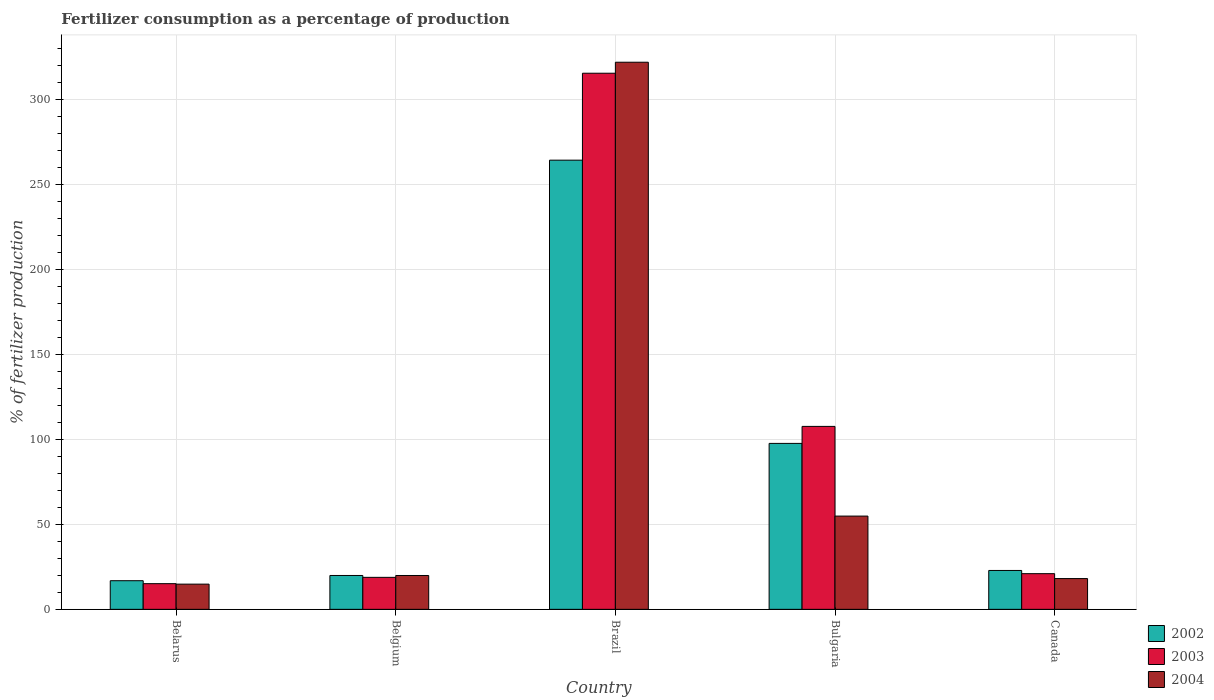How many different coloured bars are there?
Your response must be concise. 3. Are the number of bars per tick equal to the number of legend labels?
Provide a short and direct response. Yes. Are the number of bars on each tick of the X-axis equal?
Make the answer very short. Yes. What is the label of the 2nd group of bars from the left?
Give a very brief answer. Belgium. In how many cases, is the number of bars for a given country not equal to the number of legend labels?
Keep it short and to the point. 0. What is the percentage of fertilizers consumed in 2003 in Brazil?
Provide a succinct answer. 315.68. Across all countries, what is the maximum percentage of fertilizers consumed in 2003?
Offer a terse response. 315.68. Across all countries, what is the minimum percentage of fertilizers consumed in 2004?
Your answer should be very brief. 14.84. In which country was the percentage of fertilizers consumed in 2003 minimum?
Ensure brevity in your answer.  Belarus. What is the total percentage of fertilizers consumed in 2003 in the graph?
Offer a very short reply. 478.35. What is the difference between the percentage of fertilizers consumed in 2002 in Bulgaria and that in Canada?
Provide a short and direct response. 74.82. What is the difference between the percentage of fertilizers consumed in 2004 in Brazil and the percentage of fertilizers consumed in 2002 in Belarus?
Ensure brevity in your answer.  305.3. What is the average percentage of fertilizers consumed in 2003 per country?
Keep it short and to the point. 95.67. What is the difference between the percentage of fertilizers consumed of/in 2004 and percentage of fertilizers consumed of/in 2003 in Bulgaria?
Your response must be concise. -52.8. What is the ratio of the percentage of fertilizers consumed in 2002 in Belarus to that in Bulgaria?
Your answer should be compact. 0.17. Is the percentage of fertilizers consumed in 2003 in Belarus less than that in Bulgaria?
Provide a succinct answer. Yes. Is the difference between the percentage of fertilizers consumed in 2004 in Belarus and Brazil greater than the difference between the percentage of fertilizers consumed in 2003 in Belarus and Brazil?
Your answer should be very brief. No. What is the difference between the highest and the second highest percentage of fertilizers consumed in 2003?
Your response must be concise. -207.97. What is the difference between the highest and the lowest percentage of fertilizers consumed in 2003?
Your answer should be compact. 300.57. In how many countries, is the percentage of fertilizers consumed in 2002 greater than the average percentage of fertilizers consumed in 2002 taken over all countries?
Ensure brevity in your answer.  2. Is the sum of the percentage of fertilizers consumed in 2002 in Belarus and Canada greater than the maximum percentage of fertilizers consumed in 2004 across all countries?
Make the answer very short. No. What does the 1st bar from the right in Brazil represents?
Offer a very short reply. 2004. Is it the case that in every country, the sum of the percentage of fertilizers consumed in 2004 and percentage of fertilizers consumed in 2002 is greater than the percentage of fertilizers consumed in 2003?
Your answer should be compact. Yes. How many bars are there?
Ensure brevity in your answer.  15. How many countries are there in the graph?
Your response must be concise. 5. Does the graph contain any zero values?
Your answer should be compact. No. Where does the legend appear in the graph?
Provide a succinct answer. Bottom right. What is the title of the graph?
Offer a terse response. Fertilizer consumption as a percentage of production. What is the label or title of the Y-axis?
Your answer should be compact. % of fertilizer production. What is the % of fertilizer production of 2002 in Belarus?
Make the answer very short. 16.86. What is the % of fertilizer production of 2003 in Belarus?
Make the answer very short. 15.11. What is the % of fertilizer production of 2004 in Belarus?
Your answer should be compact. 14.84. What is the % of fertilizer production of 2002 in Belgium?
Provide a short and direct response. 19.94. What is the % of fertilizer production of 2003 in Belgium?
Make the answer very short. 18.83. What is the % of fertilizer production of 2004 in Belgium?
Your response must be concise. 19.93. What is the % of fertilizer production in 2002 in Brazil?
Offer a very short reply. 264.49. What is the % of fertilizer production in 2003 in Brazil?
Give a very brief answer. 315.68. What is the % of fertilizer production of 2004 in Brazil?
Make the answer very short. 322.16. What is the % of fertilizer production of 2002 in Bulgaria?
Provide a succinct answer. 97.71. What is the % of fertilizer production of 2003 in Bulgaria?
Give a very brief answer. 107.72. What is the % of fertilizer production of 2004 in Bulgaria?
Provide a short and direct response. 54.91. What is the % of fertilizer production of 2002 in Canada?
Provide a short and direct response. 22.89. What is the % of fertilizer production of 2003 in Canada?
Offer a terse response. 21. What is the % of fertilizer production of 2004 in Canada?
Offer a terse response. 18.12. Across all countries, what is the maximum % of fertilizer production in 2002?
Provide a succinct answer. 264.49. Across all countries, what is the maximum % of fertilizer production of 2003?
Keep it short and to the point. 315.68. Across all countries, what is the maximum % of fertilizer production in 2004?
Provide a succinct answer. 322.16. Across all countries, what is the minimum % of fertilizer production in 2002?
Make the answer very short. 16.86. Across all countries, what is the minimum % of fertilizer production in 2003?
Give a very brief answer. 15.11. Across all countries, what is the minimum % of fertilizer production of 2004?
Make the answer very short. 14.84. What is the total % of fertilizer production of 2002 in the graph?
Give a very brief answer. 421.89. What is the total % of fertilizer production of 2003 in the graph?
Make the answer very short. 478.35. What is the total % of fertilizer production in 2004 in the graph?
Your answer should be very brief. 429.96. What is the difference between the % of fertilizer production of 2002 in Belarus and that in Belgium?
Make the answer very short. -3.08. What is the difference between the % of fertilizer production of 2003 in Belarus and that in Belgium?
Your response must be concise. -3.72. What is the difference between the % of fertilizer production of 2004 in Belarus and that in Belgium?
Your answer should be compact. -5.09. What is the difference between the % of fertilizer production of 2002 in Belarus and that in Brazil?
Make the answer very short. -247.63. What is the difference between the % of fertilizer production in 2003 in Belarus and that in Brazil?
Make the answer very short. -300.57. What is the difference between the % of fertilizer production in 2004 in Belarus and that in Brazil?
Your answer should be very brief. -307.31. What is the difference between the % of fertilizer production of 2002 in Belarus and that in Bulgaria?
Offer a very short reply. -80.85. What is the difference between the % of fertilizer production in 2003 in Belarus and that in Bulgaria?
Give a very brief answer. -92.61. What is the difference between the % of fertilizer production of 2004 in Belarus and that in Bulgaria?
Your response must be concise. -40.07. What is the difference between the % of fertilizer production in 2002 in Belarus and that in Canada?
Ensure brevity in your answer.  -6.03. What is the difference between the % of fertilizer production in 2003 in Belarus and that in Canada?
Give a very brief answer. -5.89. What is the difference between the % of fertilizer production of 2004 in Belarus and that in Canada?
Provide a succinct answer. -3.27. What is the difference between the % of fertilizer production in 2002 in Belgium and that in Brazil?
Ensure brevity in your answer.  -244.55. What is the difference between the % of fertilizer production in 2003 in Belgium and that in Brazil?
Your answer should be very brief. -296.85. What is the difference between the % of fertilizer production of 2004 in Belgium and that in Brazil?
Your answer should be compact. -302.23. What is the difference between the % of fertilizer production of 2002 in Belgium and that in Bulgaria?
Provide a succinct answer. -77.77. What is the difference between the % of fertilizer production of 2003 in Belgium and that in Bulgaria?
Provide a succinct answer. -88.89. What is the difference between the % of fertilizer production in 2004 in Belgium and that in Bulgaria?
Keep it short and to the point. -34.98. What is the difference between the % of fertilizer production of 2002 in Belgium and that in Canada?
Make the answer very short. -2.95. What is the difference between the % of fertilizer production in 2003 in Belgium and that in Canada?
Offer a very short reply. -2.17. What is the difference between the % of fertilizer production of 2004 in Belgium and that in Canada?
Your answer should be very brief. 1.81. What is the difference between the % of fertilizer production of 2002 in Brazil and that in Bulgaria?
Keep it short and to the point. 166.78. What is the difference between the % of fertilizer production of 2003 in Brazil and that in Bulgaria?
Keep it short and to the point. 207.97. What is the difference between the % of fertilizer production of 2004 in Brazil and that in Bulgaria?
Your answer should be compact. 267.25. What is the difference between the % of fertilizer production in 2002 in Brazil and that in Canada?
Your answer should be compact. 241.6. What is the difference between the % of fertilizer production in 2003 in Brazil and that in Canada?
Provide a succinct answer. 294.68. What is the difference between the % of fertilizer production in 2004 in Brazil and that in Canada?
Provide a succinct answer. 304.04. What is the difference between the % of fertilizer production of 2002 in Bulgaria and that in Canada?
Your answer should be compact. 74.82. What is the difference between the % of fertilizer production of 2003 in Bulgaria and that in Canada?
Make the answer very short. 86.71. What is the difference between the % of fertilizer production in 2004 in Bulgaria and that in Canada?
Ensure brevity in your answer.  36.8. What is the difference between the % of fertilizer production in 2002 in Belarus and the % of fertilizer production in 2003 in Belgium?
Give a very brief answer. -1.97. What is the difference between the % of fertilizer production of 2002 in Belarus and the % of fertilizer production of 2004 in Belgium?
Offer a very short reply. -3.07. What is the difference between the % of fertilizer production of 2003 in Belarus and the % of fertilizer production of 2004 in Belgium?
Offer a very short reply. -4.82. What is the difference between the % of fertilizer production of 2002 in Belarus and the % of fertilizer production of 2003 in Brazil?
Provide a succinct answer. -298.83. What is the difference between the % of fertilizer production of 2002 in Belarus and the % of fertilizer production of 2004 in Brazil?
Provide a succinct answer. -305.3. What is the difference between the % of fertilizer production of 2003 in Belarus and the % of fertilizer production of 2004 in Brazil?
Ensure brevity in your answer.  -307.05. What is the difference between the % of fertilizer production of 2002 in Belarus and the % of fertilizer production of 2003 in Bulgaria?
Offer a terse response. -90.86. What is the difference between the % of fertilizer production of 2002 in Belarus and the % of fertilizer production of 2004 in Bulgaria?
Offer a very short reply. -38.05. What is the difference between the % of fertilizer production of 2003 in Belarus and the % of fertilizer production of 2004 in Bulgaria?
Offer a very short reply. -39.8. What is the difference between the % of fertilizer production of 2002 in Belarus and the % of fertilizer production of 2003 in Canada?
Provide a short and direct response. -4.15. What is the difference between the % of fertilizer production of 2002 in Belarus and the % of fertilizer production of 2004 in Canada?
Ensure brevity in your answer.  -1.26. What is the difference between the % of fertilizer production of 2003 in Belarus and the % of fertilizer production of 2004 in Canada?
Your answer should be compact. -3.01. What is the difference between the % of fertilizer production in 2002 in Belgium and the % of fertilizer production in 2003 in Brazil?
Ensure brevity in your answer.  -295.74. What is the difference between the % of fertilizer production in 2002 in Belgium and the % of fertilizer production in 2004 in Brazil?
Offer a very short reply. -302.22. What is the difference between the % of fertilizer production in 2003 in Belgium and the % of fertilizer production in 2004 in Brazil?
Give a very brief answer. -303.33. What is the difference between the % of fertilizer production of 2002 in Belgium and the % of fertilizer production of 2003 in Bulgaria?
Your answer should be very brief. -87.78. What is the difference between the % of fertilizer production of 2002 in Belgium and the % of fertilizer production of 2004 in Bulgaria?
Ensure brevity in your answer.  -34.97. What is the difference between the % of fertilizer production in 2003 in Belgium and the % of fertilizer production in 2004 in Bulgaria?
Offer a very short reply. -36.08. What is the difference between the % of fertilizer production in 2002 in Belgium and the % of fertilizer production in 2003 in Canada?
Offer a terse response. -1.06. What is the difference between the % of fertilizer production of 2002 in Belgium and the % of fertilizer production of 2004 in Canada?
Your answer should be compact. 1.82. What is the difference between the % of fertilizer production in 2003 in Belgium and the % of fertilizer production in 2004 in Canada?
Provide a short and direct response. 0.71. What is the difference between the % of fertilizer production in 2002 in Brazil and the % of fertilizer production in 2003 in Bulgaria?
Provide a short and direct response. 156.77. What is the difference between the % of fertilizer production of 2002 in Brazil and the % of fertilizer production of 2004 in Bulgaria?
Your answer should be compact. 209.58. What is the difference between the % of fertilizer production in 2003 in Brazil and the % of fertilizer production in 2004 in Bulgaria?
Offer a very short reply. 260.77. What is the difference between the % of fertilizer production of 2002 in Brazil and the % of fertilizer production of 2003 in Canada?
Provide a short and direct response. 243.49. What is the difference between the % of fertilizer production of 2002 in Brazil and the % of fertilizer production of 2004 in Canada?
Ensure brevity in your answer.  246.37. What is the difference between the % of fertilizer production in 2003 in Brazil and the % of fertilizer production in 2004 in Canada?
Your answer should be compact. 297.57. What is the difference between the % of fertilizer production of 2002 in Bulgaria and the % of fertilizer production of 2003 in Canada?
Provide a succinct answer. 76.71. What is the difference between the % of fertilizer production of 2002 in Bulgaria and the % of fertilizer production of 2004 in Canada?
Your answer should be compact. 79.59. What is the difference between the % of fertilizer production of 2003 in Bulgaria and the % of fertilizer production of 2004 in Canada?
Your answer should be compact. 89.6. What is the average % of fertilizer production of 2002 per country?
Your response must be concise. 84.38. What is the average % of fertilizer production in 2003 per country?
Provide a succinct answer. 95.67. What is the average % of fertilizer production in 2004 per country?
Keep it short and to the point. 85.99. What is the difference between the % of fertilizer production in 2002 and % of fertilizer production in 2003 in Belarus?
Ensure brevity in your answer.  1.75. What is the difference between the % of fertilizer production of 2002 and % of fertilizer production of 2004 in Belarus?
Provide a short and direct response. 2.01. What is the difference between the % of fertilizer production in 2003 and % of fertilizer production in 2004 in Belarus?
Keep it short and to the point. 0.27. What is the difference between the % of fertilizer production in 2002 and % of fertilizer production in 2003 in Belgium?
Provide a succinct answer. 1.11. What is the difference between the % of fertilizer production of 2002 and % of fertilizer production of 2004 in Belgium?
Your answer should be compact. 0.01. What is the difference between the % of fertilizer production of 2003 and % of fertilizer production of 2004 in Belgium?
Provide a short and direct response. -1.1. What is the difference between the % of fertilizer production in 2002 and % of fertilizer production in 2003 in Brazil?
Keep it short and to the point. -51.19. What is the difference between the % of fertilizer production of 2002 and % of fertilizer production of 2004 in Brazil?
Provide a short and direct response. -57.67. What is the difference between the % of fertilizer production of 2003 and % of fertilizer production of 2004 in Brazil?
Keep it short and to the point. -6.47. What is the difference between the % of fertilizer production of 2002 and % of fertilizer production of 2003 in Bulgaria?
Your response must be concise. -10.01. What is the difference between the % of fertilizer production in 2002 and % of fertilizer production in 2004 in Bulgaria?
Offer a very short reply. 42.8. What is the difference between the % of fertilizer production in 2003 and % of fertilizer production in 2004 in Bulgaria?
Give a very brief answer. 52.8. What is the difference between the % of fertilizer production in 2002 and % of fertilizer production in 2003 in Canada?
Keep it short and to the point. 1.88. What is the difference between the % of fertilizer production of 2002 and % of fertilizer production of 2004 in Canada?
Your answer should be compact. 4.77. What is the difference between the % of fertilizer production in 2003 and % of fertilizer production in 2004 in Canada?
Keep it short and to the point. 2.89. What is the ratio of the % of fertilizer production of 2002 in Belarus to that in Belgium?
Ensure brevity in your answer.  0.85. What is the ratio of the % of fertilizer production in 2003 in Belarus to that in Belgium?
Your response must be concise. 0.8. What is the ratio of the % of fertilizer production of 2004 in Belarus to that in Belgium?
Your answer should be compact. 0.74. What is the ratio of the % of fertilizer production in 2002 in Belarus to that in Brazil?
Offer a very short reply. 0.06. What is the ratio of the % of fertilizer production in 2003 in Belarus to that in Brazil?
Your response must be concise. 0.05. What is the ratio of the % of fertilizer production of 2004 in Belarus to that in Brazil?
Provide a short and direct response. 0.05. What is the ratio of the % of fertilizer production of 2002 in Belarus to that in Bulgaria?
Your answer should be very brief. 0.17. What is the ratio of the % of fertilizer production of 2003 in Belarus to that in Bulgaria?
Provide a succinct answer. 0.14. What is the ratio of the % of fertilizer production of 2004 in Belarus to that in Bulgaria?
Provide a succinct answer. 0.27. What is the ratio of the % of fertilizer production of 2002 in Belarus to that in Canada?
Your response must be concise. 0.74. What is the ratio of the % of fertilizer production in 2003 in Belarus to that in Canada?
Your response must be concise. 0.72. What is the ratio of the % of fertilizer production of 2004 in Belarus to that in Canada?
Make the answer very short. 0.82. What is the ratio of the % of fertilizer production of 2002 in Belgium to that in Brazil?
Offer a terse response. 0.08. What is the ratio of the % of fertilizer production in 2003 in Belgium to that in Brazil?
Your response must be concise. 0.06. What is the ratio of the % of fertilizer production of 2004 in Belgium to that in Brazil?
Make the answer very short. 0.06. What is the ratio of the % of fertilizer production in 2002 in Belgium to that in Bulgaria?
Offer a terse response. 0.2. What is the ratio of the % of fertilizer production of 2003 in Belgium to that in Bulgaria?
Keep it short and to the point. 0.17. What is the ratio of the % of fertilizer production in 2004 in Belgium to that in Bulgaria?
Provide a succinct answer. 0.36. What is the ratio of the % of fertilizer production in 2002 in Belgium to that in Canada?
Make the answer very short. 0.87. What is the ratio of the % of fertilizer production of 2003 in Belgium to that in Canada?
Your response must be concise. 0.9. What is the ratio of the % of fertilizer production in 2004 in Belgium to that in Canada?
Keep it short and to the point. 1.1. What is the ratio of the % of fertilizer production of 2002 in Brazil to that in Bulgaria?
Provide a short and direct response. 2.71. What is the ratio of the % of fertilizer production of 2003 in Brazil to that in Bulgaria?
Give a very brief answer. 2.93. What is the ratio of the % of fertilizer production in 2004 in Brazil to that in Bulgaria?
Provide a succinct answer. 5.87. What is the ratio of the % of fertilizer production in 2002 in Brazil to that in Canada?
Your answer should be compact. 11.56. What is the ratio of the % of fertilizer production in 2003 in Brazil to that in Canada?
Your answer should be compact. 15.03. What is the ratio of the % of fertilizer production in 2004 in Brazil to that in Canada?
Provide a succinct answer. 17.78. What is the ratio of the % of fertilizer production of 2002 in Bulgaria to that in Canada?
Offer a very short reply. 4.27. What is the ratio of the % of fertilizer production in 2003 in Bulgaria to that in Canada?
Provide a short and direct response. 5.13. What is the ratio of the % of fertilizer production of 2004 in Bulgaria to that in Canada?
Your answer should be compact. 3.03. What is the difference between the highest and the second highest % of fertilizer production in 2002?
Your response must be concise. 166.78. What is the difference between the highest and the second highest % of fertilizer production in 2003?
Make the answer very short. 207.97. What is the difference between the highest and the second highest % of fertilizer production of 2004?
Make the answer very short. 267.25. What is the difference between the highest and the lowest % of fertilizer production of 2002?
Ensure brevity in your answer.  247.63. What is the difference between the highest and the lowest % of fertilizer production of 2003?
Provide a short and direct response. 300.57. What is the difference between the highest and the lowest % of fertilizer production of 2004?
Ensure brevity in your answer.  307.31. 